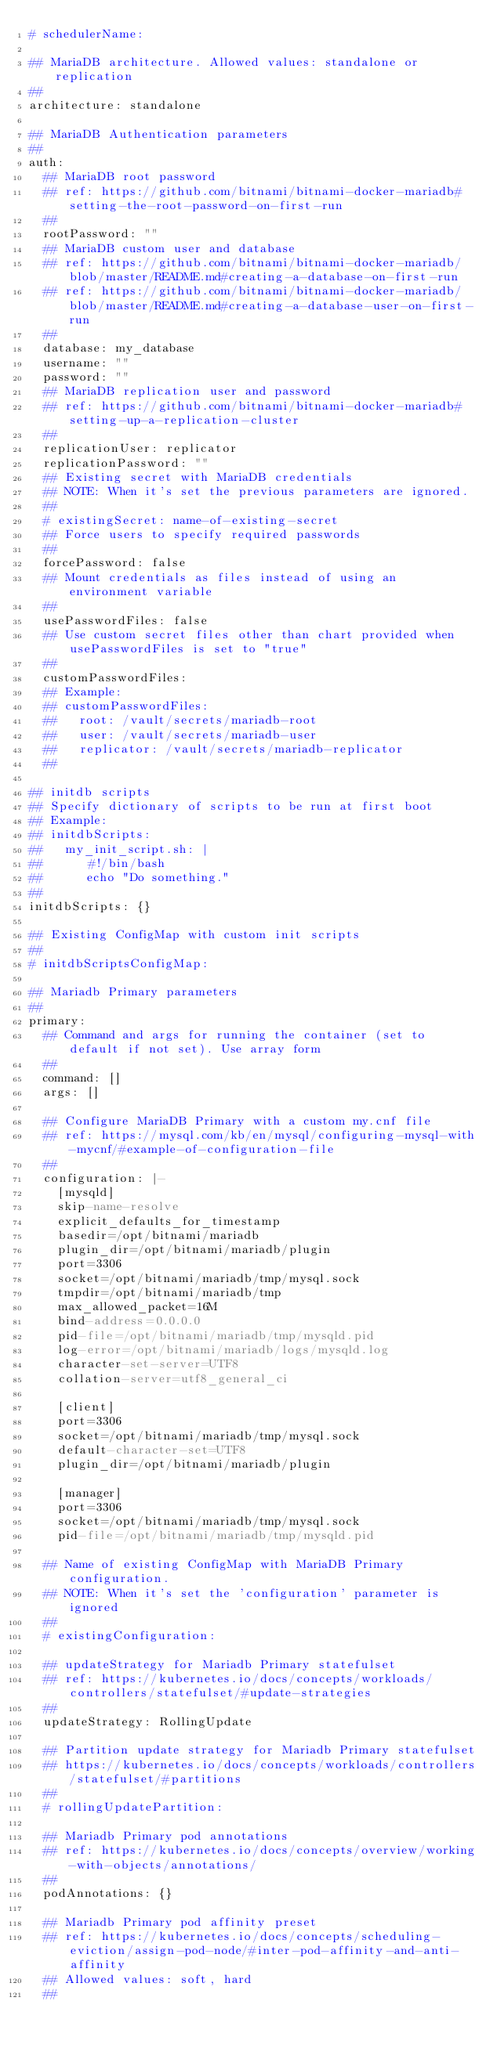Convert code to text. <code><loc_0><loc_0><loc_500><loc_500><_YAML_># schedulerName:

## MariaDB architecture. Allowed values: standalone or replication
##
architecture: standalone

## MariaDB Authentication parameters
##
auth:
  ## MariaDB root password
  ## ref: https://github.com/bitnami/bitnami-docker-mariadb#setting-the-root-password-on-first-run
  ##
  rootPassword: ""
  ## MariaDB custom user and database
  ## ref: https://github.com/bitnami/bitnami-docker-mariadb/blob/master/README.md#creating-a-database-on-first-run
  ## ref: https://github.com/bitnami/bitnami-docker-mariadb/blob/master/README.md#creating-a-database-user-on-first-run
  ##
  database: my_database
  username: ""
  password: ""
  ## MariaDB replication user and password
  ## ref: https://github.com/bitnami/bitnami-docker-mariadb#setting-up-a-replication-cluster
  ##
  replicationUser: replicator
  replicationPassword: ""
  ## Existing secret with MariaDB credentials
  ## NOTE: When it's set the previous parameters are ignored.
  ##
  # existingSecret: name-of-existing-secret
  ## Force users to specify required passwords
  ##
  forcePassword: false
  ## Mount credentials as files instead of using an environment variable
  ##
  usePasswordFiles: false
  ## Use custom secret files other than chart provided when usePasswordFiles is set to "true"
  ##
  customPasswordFiles:
  ## Example:
  ## customPasswordFiles:
  ##   root: /vault/secrets/mariadb-root
  ##   user: /vault/secrets/mariadb-user
  ##   replicator: /vault/secrets/mariadb-replicator
  ##

## initdb scripts
## Specify dictionary of scripts to be run at first boot
## Example:
## initdbScripts:
##   my_init_script.sh: |
##      #!/bin/bash
##      echo "Do something."
##
initdbScripts: {}

## Existing ConfigMap with custom init scripts
##
# initdbScriptsConfigMap:

## Mariadb Primary parameters
##
primary:
  ## Command and args for running the container (set to default if not set). Use array form
  ##
  command: []
  args: []

  ## Configure MariaDB Primary with a custom my.cnf file
  ## ref: https://mysql.com/kb/en/mysql/configuring-mysql-with-mycnf/#example-of-configuration-file
  ##
  configuration: |-
    [mysqld]
    skip-name-resolve
    explicit_defaults_for_timestamp
    basedir=/opt/bitnami/mariadb
    plugin_dir=/opt/bitnami/mariadb/plugin
    port=3306
    socket=/opt/bitnami/mariadb/tmp/mysql.sock
    tmpdir=/opt/bitnami/mariadb/tmp
    max_allowed_packet=16M
    bind-address=0.0.0.0
    pid-file=/opt/bitnami/mariadb/tmp/mysqld.pid
    log-error=/opt/bitnami/mariadb/logs/mysqld.log
    character-set-server=UTF8
    collation-server=utf8_general_ci

    [client]
    port=3306
    socket=/opt/bitnami/mariadb/tmp/mysql.sock
    default-character-set=UTF8
    plugin_dir=/opt/bitnami/mariadb/plugin

    [manager]
    port=3306
    socket=/opt/bitnami/mariadb/tmp/mysql.sock
    pid-file=/opt/bitnami/mariadb/tmp/mysqld.pid

  ## Name of existing ConfigMap with MariaDB Primary configuration.
  ## NOTE: When it's set the 'configuration' parameter is ignored
  ##
  # existingConfiguration:

  ## updateStrategy for Mariadb Primary statefulset
  ## ref: https://kubernetes.io/docs/concepts/workloads/controllers/statefulset/#update-strategies
  ##
  updateStrategy: RollingUpdate

  ## Partition update strategy for Mariadb Primary statefulset
  ## https://kubernetes.io/docs/concepts/workloads/controllers/statefulset/#partitions
  ##
  # rollingUpdatePartition:

  ## Mariadb Primary pod annotations
  ## ref: https://kubernetes.io/docs/concepts/overview/working-with-objects/annotations/
  ##
  podAnnotations: {}

  ## Mariadb Primary pod affinity preset
  ## ref: https://kubernetes.io/docs/concepts/scheduling-eviction/assign-pod-node/#inter-pod-affinity-and-anti-affinity
  ## Allowed values: soft, hard
  ##</code> 